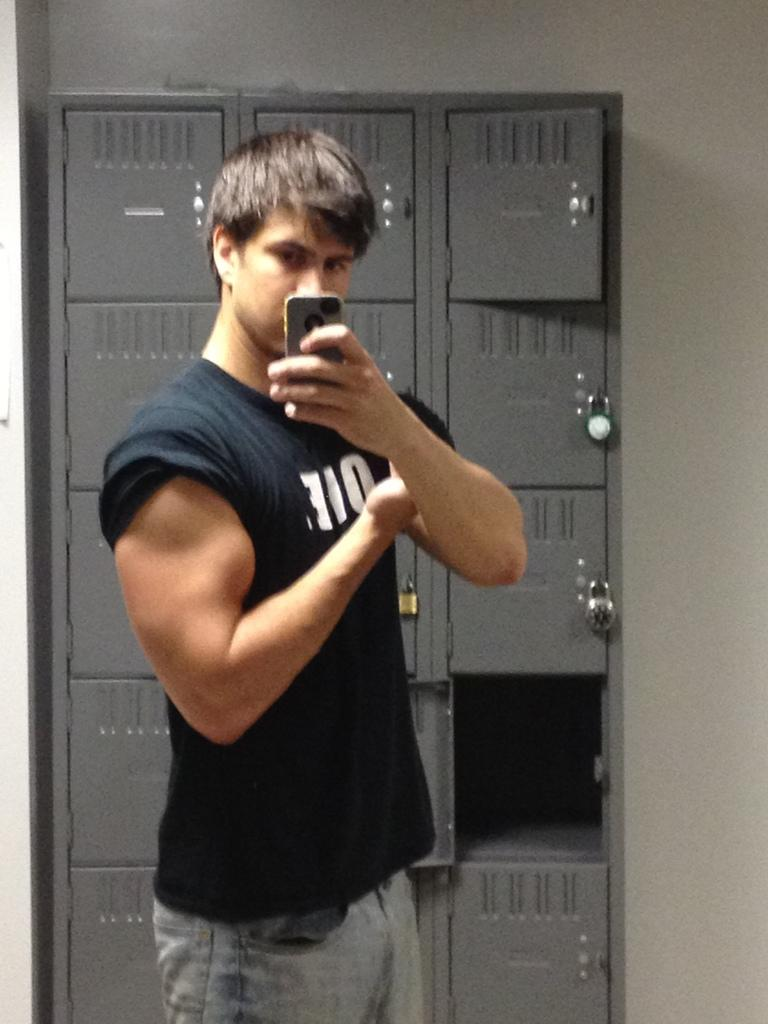What can be seen in the image? There is a person in the image. What is the person wearing? The person is wearing a T-shirt. What is the person holding in their left hand? The person is holding a phone in their left hand. What is the person doing with their right arm? The person is showing their biceps. What can be seen in the background of the image? There are lockers in the background of the image. What type of fuel is being used by the person in the image? There is no mention of fuel in the image, as it features a person holding a phone and showing their biceps. 